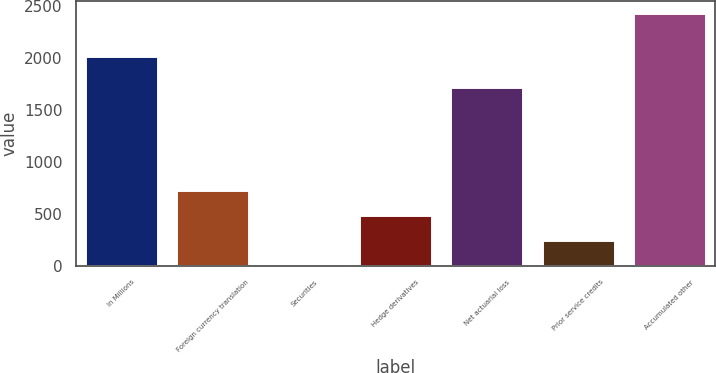Convert chart. <chart><loc_0><loc_0><loc_500><loc_500><bar_chart><fcel>In Millions<fcel>Foreign currency translation<fcel>Securities<fcel>Hedge derivatives<fcel>Net actuarial loss<fcel>Prior service credits<fcel>Accumulated other<nl><fcel>2018<fcel>730.1<fcel>2<fcel>487.4<fcel>1723.6<fcel>244.7<fcel>2429<nl></chart> 